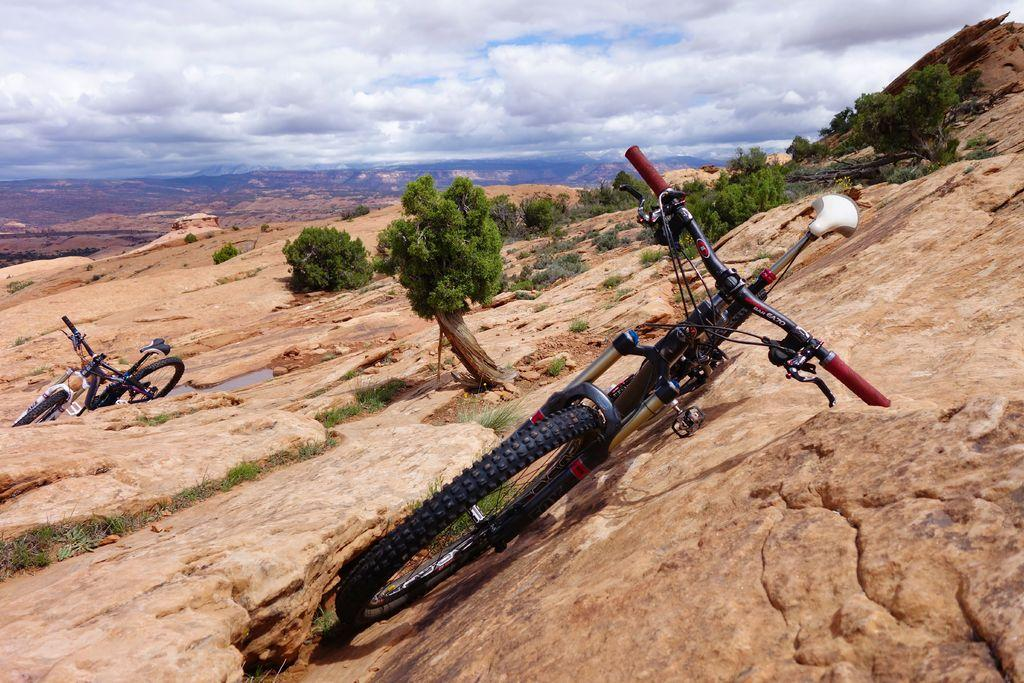How many bicycles are in the image? There are two bicycles in the image. Where are the bicycles placed? The bicycles are placed on rocks. What type of vegetation can be seen in the image? There is grass, plants, and trees in the image. What is visible at the top of the image? The sky is cloudy and visible at the top of the image. What type of key is used to unlock the bicycles in the image? There are no keys visible in the image, and the locks on the bicycles are not shown. How many sacks are present in the image? There are no sacks visible in the image. 